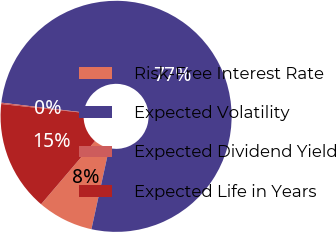Convert chart to OTSL. <chart><loc_0><loc_0><loc_500><loc_500><pie_chart><fcel>Risk-Free Interest Rate<fcel>Expected Volatility<fcel>Expected Dividend Yield<fcel>Expected Life in Years<nl><fcel>7.82%<fcel>76.53%<fcel>0.19%<fcel>15.46%<nl></chart> 